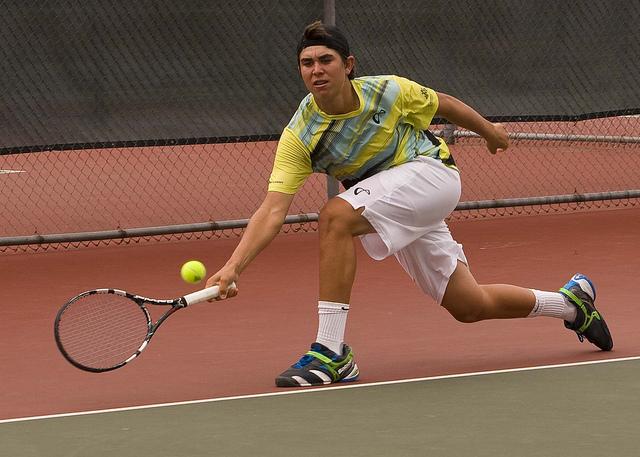Which sport is this?
Keep it brief. Tennis. What type of sneaker's is the man wearing?
Short answer required. Tennis. What is this person holding?
Short answer required. Tennis racket. How many tennis balls cast a shadow on the person?
Quick response, please. 0. 